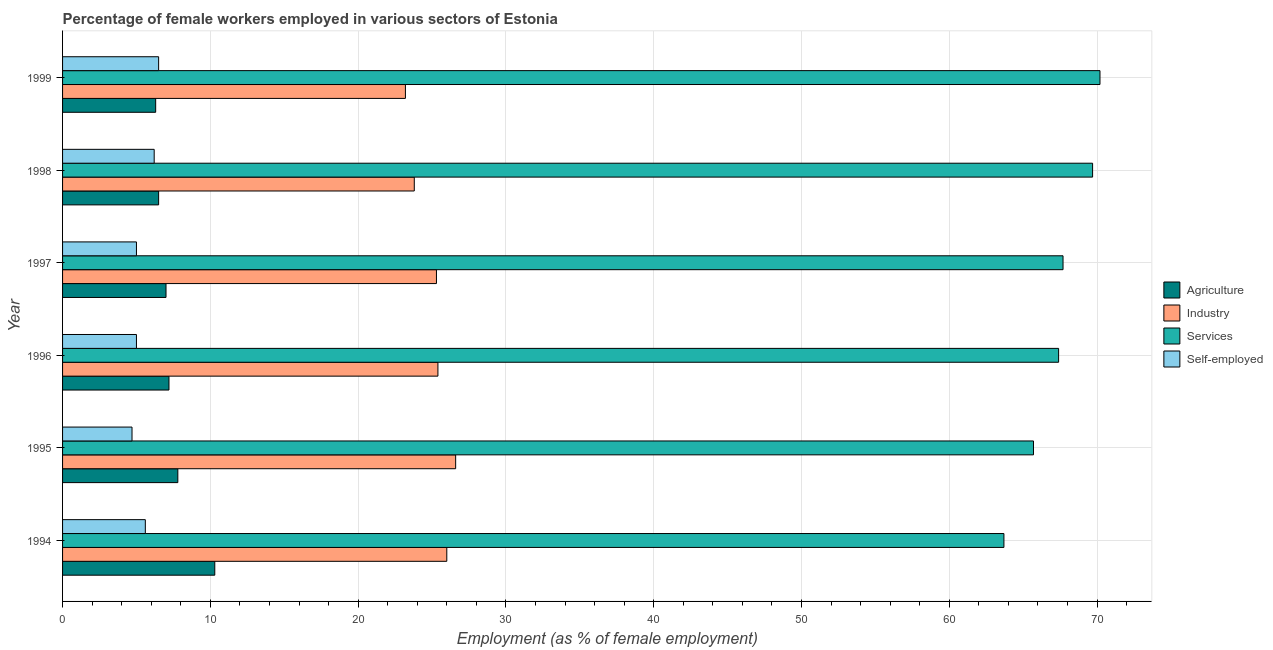How many different coloured bars are there?
Provide a short and direct response. 4. Are the number of bars on each tick of the Y-axis equal?
Offer a terse response. Yes. How many bars are there on the 1st tick from the top?
Make the answer very short. 4. How many bars are there on the 4th tick from the bottom?
Provide a succinct answer. 4. What is the percentage of self employed female workers in 1996?
Your answer should be compact. 5. Across all years, what is the maximum percentage of female workers in agriculture?
Keep it short and to the point. 10.3. Across all years, what is the minimum percentage of female workers in industry?
Provide a short and direct response. 23.2. What is the total percentage of self employed female workers in the graph?
Ensure brevity in your answer.  33. What is the difference between the percentage of female workers in agriculture in 1996 and the percentage of female workers in services in 1998?
Keep it short and to the point. -62.5. What is the average percentage of female workers in industry per year?
Keep it short and to the point. 25.05. In the year 1998, what is the difference between the percentage of female workers in agriculture and percentage of female workers in services?
Offer a very short reply. -63.2. In how many years, is the percentage of female workers in industry greater than 48 %?
Keep it short and to the point. 0. What is the ratio of the percentage of self employed female workers in 1995 to that in 1998?
Your response must be concise. 0.76. Is the difference between the percentage of female workers in industry in 1995 and 1997 greater than the difference between the percentage of self employed female workers in 1995 and 1997?
Offer a terse response. Yes. What is the difference between the highest and the second highest percentage of female workers in agriculture?
Your answer should be compact. 2.5. In how many years, is the percentage of female workers in agriculture greater than the average percentage of female workers in agriculture taken over all years?
Your response must be concise. 2. Is it the case that in every year, the sum of the percentage of female workers in industry and percentage of self employed female workers is greater than the sum of percentage of female workers in services and percentage of female workers in agriculture?
Ensure brevity in your answer.  Yes. What does the 3rd bar from the top in 1999 represents?
Ensure brevity in your answer.  Industry. What does the 1st bar from the bottom in 1996 represents?
Make the answer very short. Agriculture. Is it the case that in every year, the sum of the percentage of female workers in agriculture and percentage of female workers in industry is greater than the percentage of female workers in services?
Give a very brief answer. No. Does the graph contain any zero values?
Keep it short and to the point. No. Where does the legend appear in the graph?
Offer a terse response. Center right. What is the title of the graph?
Provide a succinct answer. Percentage of female workers employed in various sectors of Estonia. Does "Quality of public administration" appear as one of the legend labels in the graph?
Give a very brief answer. No. What is the label or title of the X-axis?
Offer a very short reply. Employment (as % of female employment). What is the Employment (as % of female employment) in Agriculture in 1994?
Make the answer very short. 10.3. What is the Employment (as % of female employment) in Services in 1994?
Make the answer very short. 63.7. What is the Employment (as % of female employment) of Self-employed in 1994?
Give a very brief answer. 5.6. What is the Employment (as % of female employment) in Agriculture in 1995?
Your answer should be very brief. 7.8. What is the Employment (as % of female employment) of Industry in 1995?
Ensure brevity in your answer.  26.6. What is the Employment (as % of female employment) of Services in 1995?
Your response must be concise. 65.7. What is the Employment (as % of female employment) of Self-employed in 1995?
Your answer should be compact. 4.7. What is the Employment (as % of female employment) in Agriculture in 1996?
Provide a short and direct response. 7.2. What is the Employment (as % of female employment) in Industry in 1996?
Your answer should be compact. 25.4. What is the Employment (as % of female employment) in Services in 1996?
Your answer should be very brief. 67.4. What is the Employment (as % of female employment) of Self-employed in 1996?
Provide a succinct answer. 5. What is the Employment (as % of female employment) of Agriculture in 1997?
Your answer should be compact. 7. What is the Employment (as % of female employment) of Industry in 1997?
Provide a short and direct response. 25.3. What is the Employment (as % of female employment) in Services in 1997?
Offer a terse response. 67.7. What is the Employment (as % of female employment) of Self-employed in 1997?
Your response must be concise. 5. What is the Employment (as % of female employment) in Agriculture in 1998?
Provide a succinct answer. 6.5. What is the Employment (as % of female employment) in Industry in 1998?
Give a very brief answer. 23.8. What is the Employment (as % of female employment) in Services in 1998?
Provide a succinct answer. 69.7. What is the Employment (as % of female employment) of Self-employed in 1998?
Provide a short and direct response. 6.2. What is the Employment (as % of female employment) in Agriculture in 1999?
Ensure brevity in your answer.  6.3. What is the Employment (as % of female employment) of Industry in 1999?
Offer a very short reply. 23.2. What is the Employment (as % of female employment) of Services in 1999?
Ensure brevity in your answer.  70.2. Across all years, what is the maximum Employment (as % of female employment) in Agriculture?
Offer a terse response. 10.3. Across all years, what is the maximum Employment (as % of female employment) in Industry?
Give a very brief answer. 26.6. Across all years, what is the maximum Employment (as % of female employment) of Services?
Provide a short and direct response. 70.2. Across all years, what is the minimum Employment (as % of female employment) of Agriculture?
Your answer should be compact. 6.3. Across all years, what is the minimum Employment (as % of female employment) of Industry?
Give a very brief answer. 23.2. Across all years, what is the minimum Employment (as % of female employment) of Services?
Your response must be concise. 63.7. Across all years, what is the minimum Employment (as % of female employment) of Self-employed?
Provide a short and direct response. 4.7. What is the total Employment (as % of female employment) of Agriculture in the graph?
Offer a very short reply. 45.1. What is the total Employment (as % of female employment) in Industry in the graph?
Your response must be concise. 150.3. What is the total Employment (as % of female employment) in Services in the graph?
Provide a short and direct response. 404.4. What is the total Employment (as % of female employment) in Self-employed in the graph?
Keep it short and to the point. 33. What is the difference between the Employment (as % of female employment) in Industry in 1994 and that in 1995?
Provide a succinct answer. -0.6. What is the difference between the Employment (as % of female employment) in Agriculture in 1994 and that in 1996?
Provide a succinct answer. 3.1. What is the difference between the Employment (as % of female employment) in Services in 1994 and that in 1996?
Keep it short and to the point. -3.7. What is the difference between the Employment (as % of female employment) of Self-employed in 1994 and that in 1996?
Offer a terse response. 0.6. What is the difference between the Employment (as % of female employment) in Industry in 1994 and that in 1997?
Offer a very short reply. 0.7. What is the difference between the Employment (as % of female employment) in Services in 1994 and that in 1998?
Provide a succinct answer. -6. What is the difference between the Employment (as % of female employment) of Industry in 1994 and that in 1999?
Provide a succinct answer. 2.8. What is the difference between the Employment (as % of female employment) in Services in 1994 and that in 1999?
Keep it short and to the point. -6.5. What is the difference between the Employment (as % of female employment) of Self-employed in 1994 and that in 1999?
Your answer should be very brief. -0.9. What is the difference between the Employment (as % of female employment) in Agriculture in 1995 and that in 1996?
Give a very brief answer. 0.6. What is the difference between the Employment (as % of female employment) of Industry in 1995 and that in 1996?
Your response must be concise. 1.2. What is the difference between the Employment (as % of female employment) in Self-employed in 1995 and that in 1996?
Your answer should be compact. -0.3. What is the difference between the Employment (as % of female employment) in Agriculture in 1995 and that in 1997?
Offer a terse response. 0.8. What is the difference between the Employment (as % of female employment) in Industry in 1995 and that in 1997?
Offer a terse response. 1.3. What is the difference between the Employment (as % of female employment) in Services in 1995 and that in 1997?
Keep it short and to the point. -2. What is the difference between the Employment (as % of female employment) in Self-employed in 1995 and that in 1997?
Make the answer very short. -0.3. What is the difference between the Employment (as % of female employment) in Industry in 1995 and that in 1998?
Your answer should be compact. 2.8. What is the difference between the Employment (as % of female employment) in Self-employed in 1995 and that in 1998?
Your response must be concise. -1.5. What is the difference between the Employment (as % of female employment) of Agriculture in 1995 and that in 1999?
Your answer should be very brief. 1.5. What is the difference between the Employment (as % of female employment) in Industry in 1995 and that in 1999?
Offer a very short reply. 3.4. What is the difference between the Employment (as % of female employment) of Self-employed in 1995 and that in 1999?
Keep it short and to the point. -1.8. What is the difference between the Employment (as % of female employment) of Industry in 1996 and that in 1998?
Offer a very short reply. 1.6. What is the difference between the Employment (as % of female employment) of Services in 1996 and that in 1998?
Offer a very short reply. -2.3. What is the difference between the Employment (as % of female employment) in Agriculture in 1996 and that in 1999?
Your answer should be compact. 0.9. What is the difference between the Employment (as % of female employment) of Industry in 1996 and that in 1999?
Provide a short and direct response. 2.2. What is the difference between the Employment (as % of female employment) of Self-employed in 1996 and that in 1999?
Offer a terse response. -1.5. What is the difference between the Employment (as % of female employment) in Self-employed in 1997 and that in 1998?
Give a very brief answer. -1.2. What is the difference between the Employment (as % of female employment) of Industry in 1997 and that in 1999?
Provide a short and direct response. 2.1. What is the difference between the Employment (as % of female employment) in Services in 1997 and that in 1999?
Ensure brevity in your answer.  -2.5. What is the difference between the Employment (as % of female employment) of Self-employed in 1997 and that in 1999?
Make the answer very short. -1.5. What is the difference between the Employment (as % of female employment) in Agriculture in 1998 and that in 1999?
Provide a succinct answer. 0.2. What is the difference between the Employment (as % of female employment) of Industry in 1998 and that in 1999?
Ensure brevity in your answer.  0.6. What is the difference between the Employment (as % of female employment) of Services in 1998 and that in 1999?
Provide a succinct answer. -0.5. What is the difference between the Employment (as % of female employment) of Agriculture in 1994 and the Employment (as % of female employment) of Industry in 1995?
Your answer should be very brief. -16.3. What is the difference between the Employment (as % of female employment) of Agriculture in 1994 and the Employment (as % of female employment) of Services in 1995?
Give a very brief answer. -55.4. What is the difference between the Employment (as % of female employment) of Industry in 1994 and the Employment (as % of female employment) of Services in 1995?
Your answer should be very brief. -39.7. What is the difference between the Employment (as % of female employment) in Industry in 1994 and the Employment (as % of female employment) in Self-employed in 1995?
Offer a terse response. 21.3. What is the difference between the Employment (as % of female employment) of Agriculture in 1994 and the Employment (as % of female employment) of Industry in 1996?
Your response must be concise. -15.1. What is the difference between the Employment (as % of female employment) of Agriculture in 1994 and the Employment (as % of female employment) of Services in 1996?
Give a very brief answer. -57.1. What is the difference between the Employment (as % of female employment) of Industry in 1994 and the Employment (as % of female employment) of Services in 1996?
Give a very brief answer. -41.4. What is the difference between the Employment (as % of female employment) in Industry in 1994 and the Employment (as % of female employment) in Self-employed in 1996?
Offer a very short reply. 21. What is the difference between the Employment (as % of female employment) of Services in 1994 and the Employment (as % of female employment) of Self-employed in 1996?
Give a very brief answer. 58.7. What is the difference between the Employment (as % of female employment) in Agriculture in 1994 and the Employment (as % of female employment) in Services in 1997?
Make the answer very short. -57.4. What is the difference between the Employment (as % of female employment) of Agriculture in 1994 and the Employment (as % of female employment) of Self-employed in 1997?
Your answer should be very brief. 5.3. What is the difference between the Employment (as % of female employment) of Industry in 1994 and the Employment (as % of female employment) of Services in 1997?
Provide a succinct answer. -41.7. What is the difference between the Employment (as % of female employment) in Industry in 1994 and the Employment (as % of female employment) in Self-employed in 1997?
Provide a succinct answer. 21. What is the difference between the Employment (as % of female employment) of Services in 1994 and the Employment (as % of female employment) of Self-employed in 1997?
Give a very brief answer. 58.7. What is the difference between the Employment (as % of female employment) in Agriculture in 1994 and the Employment (as % of female employment) in Services in 1998?
Make the answer very short. -59.4. What is the difference between the Employment (as % of female employment) of Agriculture in 1994 and the Employment (as % of female employment) of Self-employed in 1998?
Offer a very short reply. 4.1. What is the difference between the Employment (as % of female employment) of Industry in 1994 and the Employment (as % of female employment) of Services in 1998?
Your response must be concise. -43.7. What is the difference between the Employment (as % of female employment) in Industry in 1994 and the Employment (as % of female employment) in Self-employed in 1998?
Provide a short and direct response. 19.8. What is the difference between the Employment (as % of female employment) of Services in 1994 and the Employment (as % of female employment) of Self-employed in 1998?
Offer a very short reply. 57.5. What is the difference between the Employment (as % of female employment) in Agriculture in 1994 and the Employment (as % of female employment) in Industry in 1999?
Offer a terse response. -12.9. What is the difference between the Employment (as % of female employment) in Agriculture in 1994 and the Employment (as % of female employment) in Services in 1999?
Make the answer very short. -59.9. What is the difference between the Employment (as % of female employment) of Agriculture in 1994 and the Employment (as % of female employment) of Self-employed in 1999?
Offer a very short reply. 3.8. What is the difference between the Employment (as % of female employment) in Industry in 1994 and the Employment (as % of female employment) in Services in 1999?
Give a very brief answer. -44.2. What is the difference between the Employment (as % of female employment) of Industry in 1994 and the Employment (as % of female employment) of Self-employed in 1999?
Offer a terse response. 19.5. What is the difference between the Employment (as % of female employment) of Services in 1994 and the Employment (as % of female employment) of Self-employed in 1999?
Provide a succinct answer. 57.2. What is the difference between the Employment (as % of female employment) in Agriculture in 1995 and the Employment (as % of female employment) in Industry in 1996?
Offer a terse response. -17.6. What is the difference between the Employment (as % of female employment) of Agriculture in 1995 and the Employment (as % of female employment) of Services in 1996?
Your answer should be very brief. -59.6. What is the difference between the Employment (as % of female employment) of Agriculture in 1995 and the Employment (as % of female employment) of Self-employed in 1996?
Offer a very short reply. 2.8. What is the difference between the Employment (as % of female employment) of Industry in 1995 and the Employment (as % of female employment) of Services in 1996?
Keep it short and to the point. -40.8. What is the difference between the Employment (as % of female employment) in Industry in 1995 and the Employment (as % of female employment) in Self-employed in 1996?
Give a very brief answer. 21.6. What is the difference between the Employment (as % of female employment) of Services in 1995 and the Employment (as % of female employment) of Self-employed in 1996?
Provide a succinct answer. 60.7. What is the difference between the Employment (as % of female employment) of Agriculture in 1995 and the Employment (as % of female employment) of Industry in 1997?
Offer a very short reply. -17.5. What is the difference between the Employment (as % of female employment) of Agriculture in 1995 and the Employment (as % of female employment) of Services in 1997?
Ensure brevity in your answer.  -59.9. What is the difference between the Employment (as % of female employment) in Agriculture in 1995 and the Employment (as % of female employment) in Self-employed in 1997?
Provide a short and direct response. 2.8. What is the difference between the Employment (as % of female employment) of Industry in 1995 and the Employment (as % of female employment) of Services in 1997?
Your answer should be compact. -41.1. What is the difference between the Employment (as % of female employment) of Industry in 1995 and the Employment (as % of female employment) of Self-employed in 1997?
Your response must be concise. 21.6. What is the difference between the Employment (as % of female employment) in Services in 1995 and the Employment (as % of female employment) in Self-employed in 1997?
Offer a terse response. 60.7. What is the difference between the Employment (as % of female employment) of Agriculture in 1995 and the Employment (as % of female employment) of Industry in 1998?
Your response must be concise. -16. What is the difference between the Employment (as % of female employment) of Agriculture in 1995 and the Employment (as % of female employment) of Services in 1998?
Provide a short and direct response. -61.9. What is the difference between the Employment (as % of female employment) in Agriculture in 1995 and the Employment (as % of female employment) in Self-employed in 1998?
Give a very brief answer. 1.6. What is the difference between the Employment (as % of female employment) of Industry in 1995 and the Employment (as % of female employment) of Services in 1998?
Give a very brief answer. -43.1. What is the difference between the Employment (as % of female employment) of Industry in 1995 and the Employment (as % of female employment) of Self-employed in 1998?
Offer a terse response. 20.4. What is the difference between the Employment (as % of female employment) of Services in 1995 and the Employment (as % of female employment) of Self-employed in 1998?
Your answer should be very brief. 59.5. What is the difference between the Employment (as % of female employment) in Agriculture in 1995 and the Employment (as % of female employment) in Industry in 1999?
Keep it short and to the point. -15.4. What is the difference between the Employment (as % of female employment) in Agriculture in 1995 and the Employment (as % of female employment) in Services in 1999?
Your answer should be very brief. -62.4. What is the difference between the Employment (as % of female employment) in Agriculture in 1995 and the Employment (as % of female employment) in Self-employed in 1999?
Provide a short and direct response. 1.3. What is the difference between the Employment (as % of female employment) in Industry in 1995 and the Employment (as % of female employment) in Services in 1999?
Provide a short and direct response. -43.6. What is the difference between the Employment (as % of female employment) of Industry in 1995 and the Employment (as % of female employment) of Self-employed in 1999?
Ensure brevity in your answer.  20.1. What is the difference between the Employment (as % of female employment) of Services in 1995 and the Employment (as % of female employment) of Self-employed in 1999?
Offer a terse response. 59.2. What is the difference between the Employment (as % of female employment) in Agriculture in 1996 and the Employment (as % of female employment) in Industry in 1997?
Your response must be concise. -18.1. What is the difference between the Employment (as % of female employment) of Agriculture in 1996 and the Employment (as % of female employment) of Services in 1997?
Your answer should be very brief. -60.5. What is the difference between the Employment (as % of female employment) in Agriculture in 1996 and the Employment (as % of female employment) in Self-employed in 1997?
Your answer should be very brief. 2.2. What is the difference between the Employment (as % of female employment) of Industry in 1996 and the Employment (as % of female employment) of Services in 1997?
Provide a short and direct response. -42.3. What is the difference between the Employment (as % of female employment) in Industry in 1996 and the Employment (as % of female employment) in Self-employed in 1997?
Offer a very short reply. 20.4. What is the difference between the Employment (as % of female employment) in Services in 1996 and the Employment (as % of female employment) in Self-employed in 1997?
Provide a succinct answer. 62.4. What is the difference between the Employment (as % of female employment) of Agriculture in 1996 and the Employment (as % of female employment) of Industry in 1998?
Provide a succinct answer. -16.6. What is the difference between the Employment (as % of female employment) in Agriculture in 1996 and the Employment (as % of female employment) in Services in 1998?
Offer a terse response. -62.5. What is the difference between the Employment (as % of female employment) of Industry in 1996 and the Employment (as % of female employment) of Services in 1998?
Ensure brevity in your answer.  -44.3. What is the difference between the Employment (as % of female employment) in Industry in 1996 and the Employment (as % of female employment) in Self-employed in 1998?
Provide a short and direct response. 19.2. What is the difference between the Employment (as % of female employment) of Services in 1996 and the Employment (as % of female employment) of Self-employed in 1998?
Make the answer very short. 61.2. What is the difference between the Employment (as % of female employment) of Agriculture in 1996 and the Employment (as % of female employment) of Services in 1999?
Ensure brevity in your answer.  -63. What is the difference between the Employment (as % of female employment) in Industry in 1996 and the Employment (as % of female employment) in Services in 1999?
Give a very brief answer. -44.8. What is the difference between the Employment (as % of female employment) of Services in 1996 and the Employment (as % of female employment) of Self-employed in 1999?
Offer a terse response. 60.9. What is the difference between the Employment (as % of female employment) of Agriculture in 1997 and the Employment (as % of female employment) of Industry in 1998?
Make the answer very short. -16.8. What is the difference between the Employment (as % of female employment) in Agriculture in 1997 and the Employment (as % of female employment) in Services in 1998?
Provide a succinct answer. -62.7. What is the difference between the Employment (as % of female employment) in Agriculture in 1997 and the Employment (as % of female employment) in Self-employed in 1998?
Provide a succinct answer. 0.8. What is the difference between the Employment (as % of female employment) in Industry in 1997 and the Employment (as % of female employment) in Services in 1998?
Your answer should be very brief. -44.4. What is the difference between the Employment (as % of female employment) in Services in 1997 and the Employment (as % of female employment) in Self-employed in 1998?
Ensure brevity in your answer.  61.5. What is the difference between the Employment (as % of female employment) of Agriculture in 1997 and the Employment (as % of female employment) of Industry in 1999?
Provide a succinct answer. -16.2. What is the difference between the Employment (as % of female employment) of Agriculture in 1997 and the Employment (as % of female employment) of Services in 1999?
Offer a very short reply. -63.2. What is the difference between the Employment (as % of female employment) of Industry in 1997 and the Employment (as % of female employment) of Services in 1999?
Keep it short and to the point. -44.9. What is the difference between the Employment (as % of female employment) of Industry in 1997 and the Employment (as % of female employment) of Self-employed in 1999?
Make the answer very short. 18.8. What is the difference between the Employment (as % of female employment) of Services in 1997 and the Employment (as % of female employment) of Self-employed in 1999?
Make the answer very short. 61.2. What is the difference between the Employment (as % of female employment) in Agriculture in 1998 and the Employment (as % of female employment) in Industry in 1999?
Keep it short and to the point. -16.7. What is the difference between the Employment (as % of female employment) of Agriculture in 1998 and the Employment (as % of female employment) of Services in 1999?
Offer a very short reply. -63.7. What is the difference between the Employment (as % of female employment) in Industry in 1998 and the Employment (as % of female employment) in Services in 1999?
Your response must be concise. -46.4. What is the difference between the Employment (as % of female employment) of Services in 1998 and the Employment (as % of female employment) of Self-employed in 1999?
Your answer should be compact. 63.2. What is the average Employment (as % of female employment) in Agriculture per year?
Give a very brief answer. 7.52. What is the average Employment (as % of female employment) of Industry per year?
Provide a succinct answer. 25.05. What is the average Employment (as % of female employment) in Services per year?
Your answer should be compact. 67.4. What is the average Employment (as % of female employment) in Self-employed per year?
Provide a succinct answer. 5.5. In the year 1994, what is the difference between the Employment (as % of female employment) in Agriculture and Employment (as % of female employment) in Industry?
Your response must be concise. -15.7. In the year 1994, what is the difference between the Employment (as % of female employment) in Agriculture and Employment (as % of female employment) in Services?
Offer a very short reply. -53.4. In the year 1994, what is the difference between the Employment (as % of female employment) of Industry and Employment (as % of female employment) of Services?
Your response must be concise. -37.7. In the year 1994, what is the difference between the Employment (as % of female employment) in Industry and Employment (as % of female employment) in Self-employed?
Your response must be concise. 20.4. In the year 1994, what is the difference between the Employment (as % of female employment) in Services and Employment (as % of female employment) in Self-employed?
Your response must be concise. 58.1. In the year 1995, what is the difference between the Employment (as % of female employment) in Agriculture and Employment (as % of female employment) in Industry?
Your answer should be compact. -18.8. In the year 1995, what is the difference between the Employment (as % of female employment) of Agriculture and Employment (as % of female employment) of Services?
Ensure brevity in your answer.  -57.9. In the year 1995, what is the difference between the Employment (as % of female employment) of Industry and Employment (as % of female employment) of Services?
Ensure brevity in your answer.  -39.1. In the year 1995, what is the difference between the Employment (as % of female employment) in Industry and Employment (as % of female employment) in Self-employed?
Your response must be concise. 21.9. In the year 1995, what is the difference between the Employment (as % of female employment) in Services and Employment (as % of female employment) in Self-employed?
Provide a succinct answer. 61. In the year 1996, what is the difference between the Employment (as % of female employment) of Agriculture and Employment (as % of female employment) of Industry?
Offer a terse response. -18.2. In the year 1996, what is the difference between the Employment (as % of female employment) of Agriculture and Employment (as % of female employment) of Services?
Keep it short and to the point. -60.2. In the year 1996, what is the difference between the Employment (as % of female employment) in Agriculture and Employment (as % of female employment) in Self-employed?
Keep it short and to the point. 2.2. In the year 1996, what is the difference between the Employment (as % of female employment) of Industry and Employment (as % of female employment) of Services?
Ensure brevity in your answer.  -42. In the year 1996, what is the difference between the Employment (as % of female employment) in Industry and Employment (as % of female employment) in Self-employed?
Your answer should be compact. 20.4. In the year 1996, what is the difference between the Employment (as % of female employment) in Services and Employment (as % of female employment) in Self-employed?
Your response must be concise. 62.4. In the year 1997, what is the difference between the Employment (as % of female employment) of Agriculture and Employment (as % of female employment) of Industry?
Offer a terse response. -18.3. In the year 1997, what is the difference between the Employment (as % of female employment) in Agriculture and Employment (as % of female employment) in Services?
Ensure brevity in your answer.  -60.7. In the year 1997, what is the difference between the Employment (as % of female employment) of Industry and Employment (as % of female employment) of Services?
Your answer should be very brief. -42.4. In the year 1997, what is the difference between the Employment (as % of female employment) in Industry and Employment (as % of female employment) in Self-employed?
Give a very brief answer. 20.3. In the year 1997, what is the difference between the Employment (as % of female employment) in Services and Employment (as % of female employment) in Self-employed?
Ensure brevity in your answer.  62.7. In the year 1998, what is the difference between the Employment (as % of female employment) of Agriculture and Employment (as % of female employment) of Industry?
Make the answer very short. -17.3. In the year 1998, what is the difference between the Employment (as % of female employment) in Agriculture and Employment (as % of female employment) in Services?
Your response must be concise. -63.2. In the year 1998, what is the difference between the Employment (as % of female employment) in Agriculture and Employment (as % of female employment) in Self-employed?
Keep it short and to the point. 0.3. In the year 1998, what is the difference between the Employment (as % of female employment) of Industry and Employment (as % of female employment) of Services?
Offer a terse response. -45.9. In the year 1998, what is the difference between the Employment (as % of female employment) of Services and Employment (as % of female employment) of Self-employed?
Your answer should be compact. 63.5. In the year 1999, what is the difference between the Employment (as % of female employment) in Agriculture and Employment (as % of female employment) in Industry?
Offer a terse response. -16.9. In the year 1999, what is the difference between the Employment (as % of female employment) of Agriculture and Employment (as % of female employment) of Services?
Your answer should be very brief. -63.9. In the year 1999, what is the difference between the Employment (as % of female employment) of Industry and Employment (as % of female employment) of Services?
Your answer should be compact. -47. In the year 1999, what is the difference between the Employment (as % of female employment) of Industry and Employment (as % of female employment) of Self-employed?
Your answer should be very brief. 16.7. In the year 1999, what is the difference between the Employment (as % of female employment) of Services and Employment (as % of female employment) of Self-employed?
Give a very brief answer. 63.7. What is the ratio of the Employment (as % of female employment) in Agriculture in 1994 to that in 1995?
Provide a short and direct response. 1.32. What is the ratio of the Employment (as % of female employment) of Industry in 1994 to that in 1995?
Offer a terse response. 0.98. What is the ratio of the Employment (as % of female employment) in Services in 1994 to that in 1995?
Your answer should be very brief. 0.97. What is the ratio of the Employment (as % of female employment) in Self-employed in 1994 to that in 1995?
Provide a succinct answer. 1.19. What is the ratio of the Employment (as % of female employment) of Agriculture in 1994 to that in 1996?
Give a very brief answer. 1.43. What is the ratio of the Employment (as % of female employment) of Industry in 1994 to that in 1996?
Your response must be concise. 1.02. What is the ratio of the Employment (as % of female employment) of Services in 1994 to that in 1996?
Provide a succinct answer. 0.95. What is the ratio of the Employment (as % of female employment) of Self-employed in 1994 to that in 1996?
Your answer should be compact. 1.12. What is the ratio of the Employment (as % of female employment) in Agriculture in 1994 to that in 1997?
Your answer should be compact. 1.47. What is the ratio of the Employment (as % of female employment) in Industry in 1994 to that in 1997?
Your answer should be compact. 1.03. What is the ratio of the Employment (as % of female employment) of Services in 1994 to that in 1997?
Give a very brief answer. 0.94. What is the ratio of the Employment (as % of female employment) in Self-employed in 1994 to that in 1997?
Your answer should be very brief. 1.12. What is the ratio of the Employment (as % of female employment) in Agriculture in 1994 to that in 1998?
Give a very brief answer. 1.58. What is the ratio of the Employment (as % of female employment) of Industry in 1994 to that in 1998?
Give a very brief answer. 1.09. What is the ratio of the Employment (as % of female employment) in Services in 1994 to that in 1998?
Give a very brief answer. 0.91. What is the ratio of the Employment (as % of female employment) in Self-employed in 1994 to that in 1998?
Keep it short and to the point. 0.9. What is the ratio of the Employment (as % of female employment) of Agriculture in 1994 to that in 1999?
Keep it short and to the point. 1.63. What is the ratio of the Employment (as % of female employment) in Industry in 1994 to that in 1999?
Your answer should be compact. 1.12. What is the ratio of the Employment (as % of female employment) of Services in 1994 to that in 1999?
Your answer should be compact. 0.91. What is the ratio of the Employment (as % of female employment) of Self-employed in 1994 to that in 1999?
Offer a very short reply. 0.86. What is the ratio of the Employment (as % of female employment) in Agriculture in 1995 to that in 1996?
Offer a terse response. 1.08. What is the ratio of the Employment (as % of female employment) of Industry in 1995 to that in 1996?
Your answer should be very brief. 1.05. What is the ratio of the Employment (as % of female employment) in Services in 1995 to that in 1996?
Offer a terse response. 0.97. What is the ratio of the Employment (as % of female employment) of Self-employed in 1995 to that in 1996?
Keep it short and to the point. 0.94. What is the ratio of the Employment (as % of female employment) of Agriculture in 1995 to that in 1997?
Provide a succinct answer. 1.11. What is the ratio of the Employment (as % of female employment) in Industry in 1995 to that in 1997?
Keep it short and to the point. 1.05. What is the ratio of the Employment (as % of female employment) of Services in 1995 to that in 1997?
Offer a very short reply. 0.97. What is the ratio of the Employment (as % of female employment) in Self-employed in 1995 to that in 1997?
Offer a terse response. 0.94. What is the ratio of the Employment (as % of female employment) of Industry in 1995 to that in 1998?
Ensure brevity in your answer.  1.12. What is the ratio of the Employment (as % of female employment) in Services in 1995 to that in 1998?
Give a very brief answer. 0.94. What is the ratio of the Employment (as % of female employment) in Self-employed in 1995 to that in 1998?
Your response must be concise. 0.76. What is the ratio of the Employment (as % of female employment) of Agriculture in 1995 to that in 1999?
Your response must be concise. 1.24. What is the ratio of the Employment (as % of female employment) of Industry in 1995 to that in 1999?
Your answer should be very brief. 1.15. What is the ratio of the Employment (as % of female employment) of Services in 1995 to that in 1999?
Ensure brevity in your answer.  0.94. What is the ratio of the Employment (as % of female employment) in Self-employed in 1995 to that in 1999?
Your answer should be compact. 0.72. What is the ratio of the Employment (as % of female employment) in Agriculture in 1996 to that in 1997?
Provide a succinct answer. 1.03. What is the ratio of the Employment (as % of female employment) of Industry in 1996 to that in 1997?
Give a very brief answer. 1. What is the ratio of the Employment (as % of female employment) of Services in 1996 to that in 1997?
Give a very brief answer. 1. What is the ratio of the Employment (as % of female employment) in Self-employed in 1996 to that in 1997?
Offer a very short reply. 1. What is the ratio of the Employment (as % of female employment) of Agriculture in 1996 to that in 1998?
Your answer should be very brief. 1.11. What is the ratio of the Employment (as % of female employment) in Industry in 1996 to that in 1998?
Your answer should be very brief. 1.07. What is the ratio of the Employment (as % of female employment) in Self-employed in 1996 to that in 1998?
Keep it short and to the point. 0.81. What is the ratio of the Employment (as % of female employment) in Agriculture in 1996 to that in 1999?
Provide a succinct answer. 1.14. What is the ratio of the Employment (as % of female employment) of Industry in 1996 to that in 1999?
Your answer should be very brief. 1.09. What is the ratio of the Employment (as % of female employment) in Services in 1996 to that in 1999?
Give a very brief answer. 0.96. What is the ratio of the Employment (as % of female employment) in Self-employed in 1996 to that in 1999?
Ensure brevity in your answer.  0.77. What is the ratio of the Employment (as % of female employment) in Agriculture in 1997 to that in 1998?
Give a very brief answer. 1.08. What is the ratio of the Employment (as % of female employment) of Industry in 1997 to that in 1998?
Give a very brief answer. 1.06. What is the ratio of the Employment (as % of female employment) of Services in 1997 to that in 1998?
Give a very brief answer. 0.97. What is the ratio of the Employment (as % of female employment) in Self-employed in 1997 to that in 1998?
Give a very brief answer. 0.81. What is the ratio of the Employment (as % of female employment) of Agriculture in 1997 to that in 1999?
Provide a succinct answer. 1.11. What is the ratio of the Employment (as % of female employment) of Industry in 1997 to that in 1999?
Offer a very short reply. 1.09. What is the ratio of the Employment (as % of female employment) in Services in 1997 to that in 1999?
Keep it short and to the point. 0.96. What is the ratio of the Employment (as % of female employment) of Self-employed in 1997 to that in 1999?
Your answer should be very brief. 0.77. What is the ratio of the Employment (as % of female employment) of Agriculture in 1998 to that in 1999?
Make the answer very short. 1.03. What is the ratio of the Employment (as % of female employment) in Industry in 1998 to that in 1999?
Keep it short and to the point. 1.03. What is the ratio of the Employment (as % of female employment) in Self-employed in 1998 to that in 1999?
Your answer should be very brief. 0.95. What is the difference between the highest and the second highest Employment (as % of female employment) of Agriculture?
Your answer should be compact. 2.5. What is the difference between the highest and the second highest Employment (as % of female employment) of Industry?
Offer a very short reply. 0.6. What is the difference between the highest and the lowest Employment (as % of female employment) in Agriculture?
Your answer should be compact. 4. What is the difference between the highest and the lowest Employment (as % of female employment) in Industry?
Your response must be concise. 3.4. What is the difference between the highest and the lowest Employment (as % of female employment) in Self-employed?
Your answer should be very brief. 1.8. 